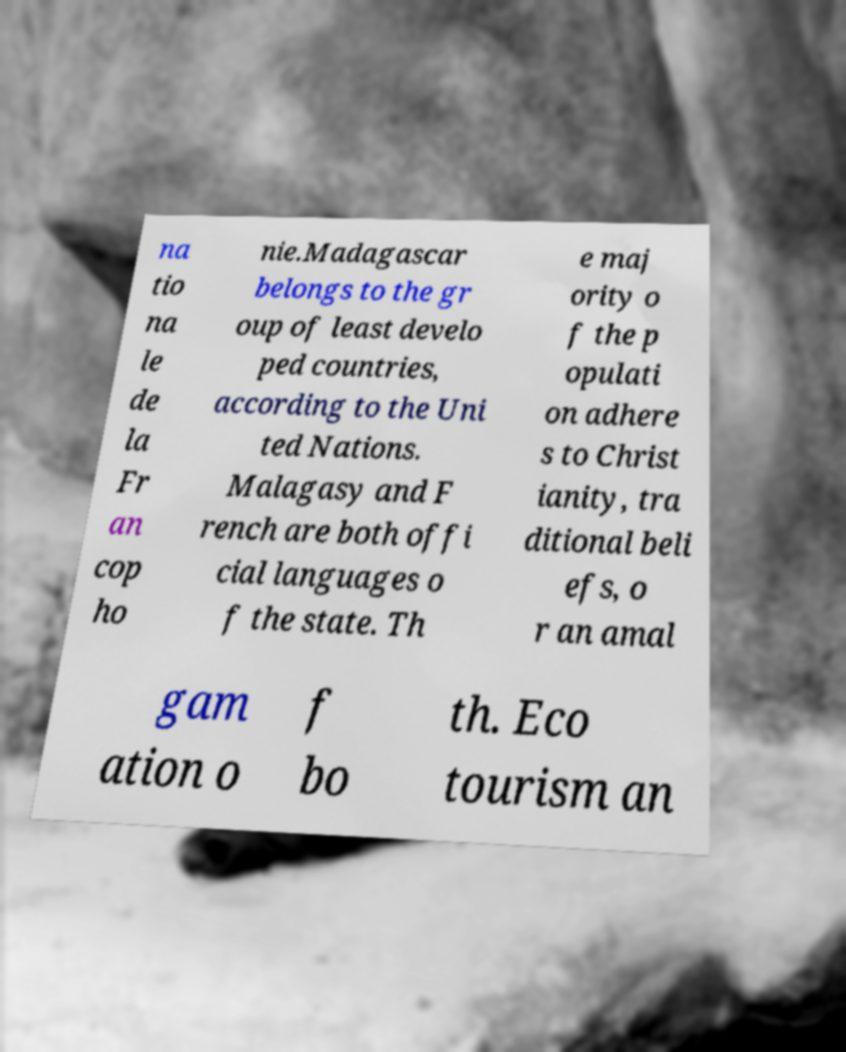Can you accurately transcribe the text from the provided image for me? na tio na le de la Fr an cop ho nie.Madagascar belongs to the gr oup of least develo ped countries, according to the Uni ted Nations. Malagasy and F rench are both offi cial languages o f the state. Th e maj ority o f the p opulati on adhere s to Christ ianity, tra ditional beli efs, o r an amal gam ation o f bo th. Eco tourism an 